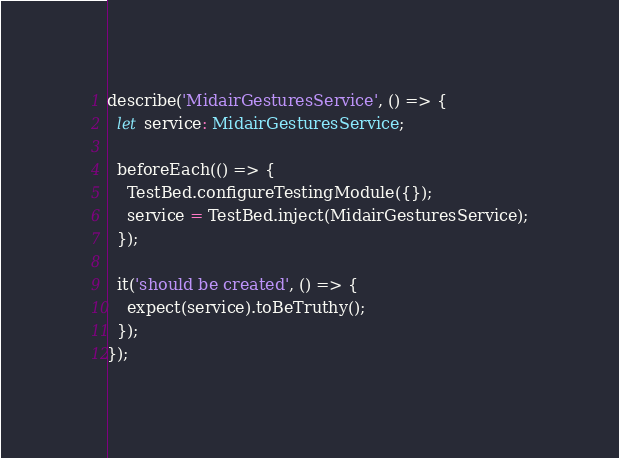<code> <loc_0><loc_0><loc_500><loc_500><_TypeScript_>describe('MidairGesturesService', () => {
  let service: MidairGesturesService;

  beforeEach(() => {
    TestBed.configureTestingModule({});
    service = TestBed.inject(MidairGesturesService);
  });

  it('should be created', () => {
    expect(service).toBeTruthy();
  });
});
</code> 